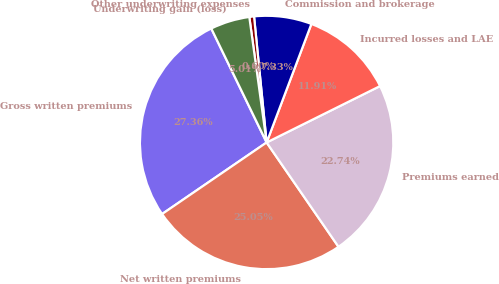Convert chart. <chart><loc_0><loc_0><loc_500><loc_500><pie_chart><fcel>Gross written premiums<fcel>Net written premiums<fcel>Premiums earned<fcel>Incurred losses and LAE<fcel>Commission and brokerage<fcel>Other underwriting expenses<fcel>Underwriting gain (loss)<nl><fcel>27.36%<fcel>25.05%<fcel>22.74%<fcel>11.91%<fcel>7.33%<fcel>0.6%<fcel>5.01%<nl></chart> 